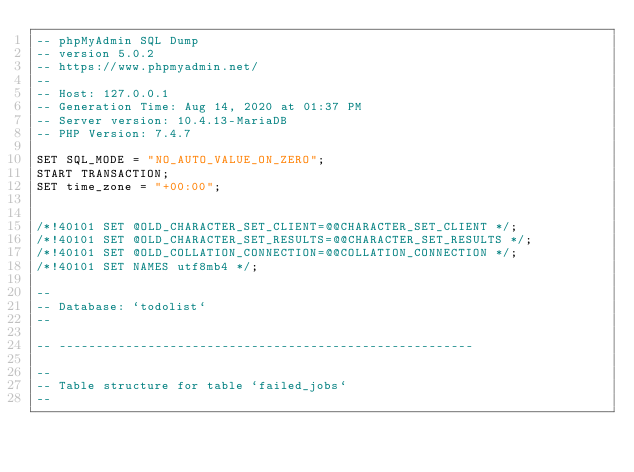Convert code to text. <code><loc_0><loc_0><loc_500><loc_500><_SQL_>-- phpMyAdmin SQL Dump
-- version 5.0.2
-- https://www.phpmyadmin.net/
--
-- Host: 127.0.0.1
-- Generation Time: Aug 14, 2020 at 01:37 PM
-- Server version: 10.4.13-MariaDB
-- PHP Version: 7.4.7

SET SQL_MODE = "NO_AUTO_VALUE_ON_ZERO";
START TRANSACTION;
SET time_zone = "+00:00";


/*!40101 SET @OLD_CHARACTER_SET_CLIENT=@@CHARACTER_SET_CLIENT */;
/*!40101 SET @OLD_CHARACTER_SET_RESULTS=@@CHARACTER_SET_RESULTS */;
/*!40101 SET @OLD_COLLATION_CONNECTION=@@COLLATION_CONNECTION */;
/*!40101 SET NAMES utf8mb4 */;

--
-- Database: `todolist`
--

-- --------------------------------------------------------

--
-- Table structure for table `failed_jobs`
--
</code> 